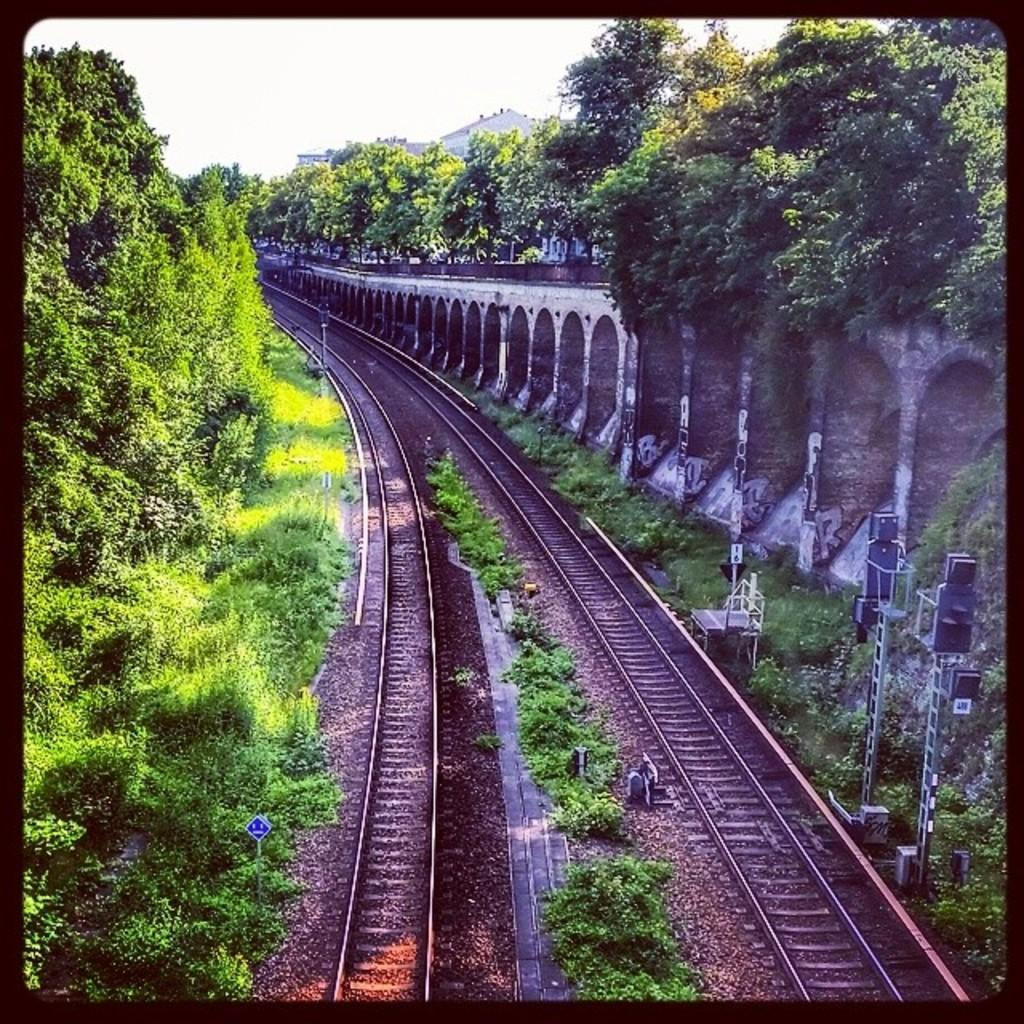What can be seen on the ground in the image? There are tracks visible in the image. What type of structure is located on the right corner of the image? There is a huge arch wall on the right corner of the image. What type of vegetation is present in the image? There are trees in the image. What type of verse can be seen written on the trees in the image? There is no verse written on the trees in the image; only the tracks, arch wall, and trees are present. What time of day is depicted in the image, considering the presence of night? The image does not depict night; it is not mentioned in the provided facts. 